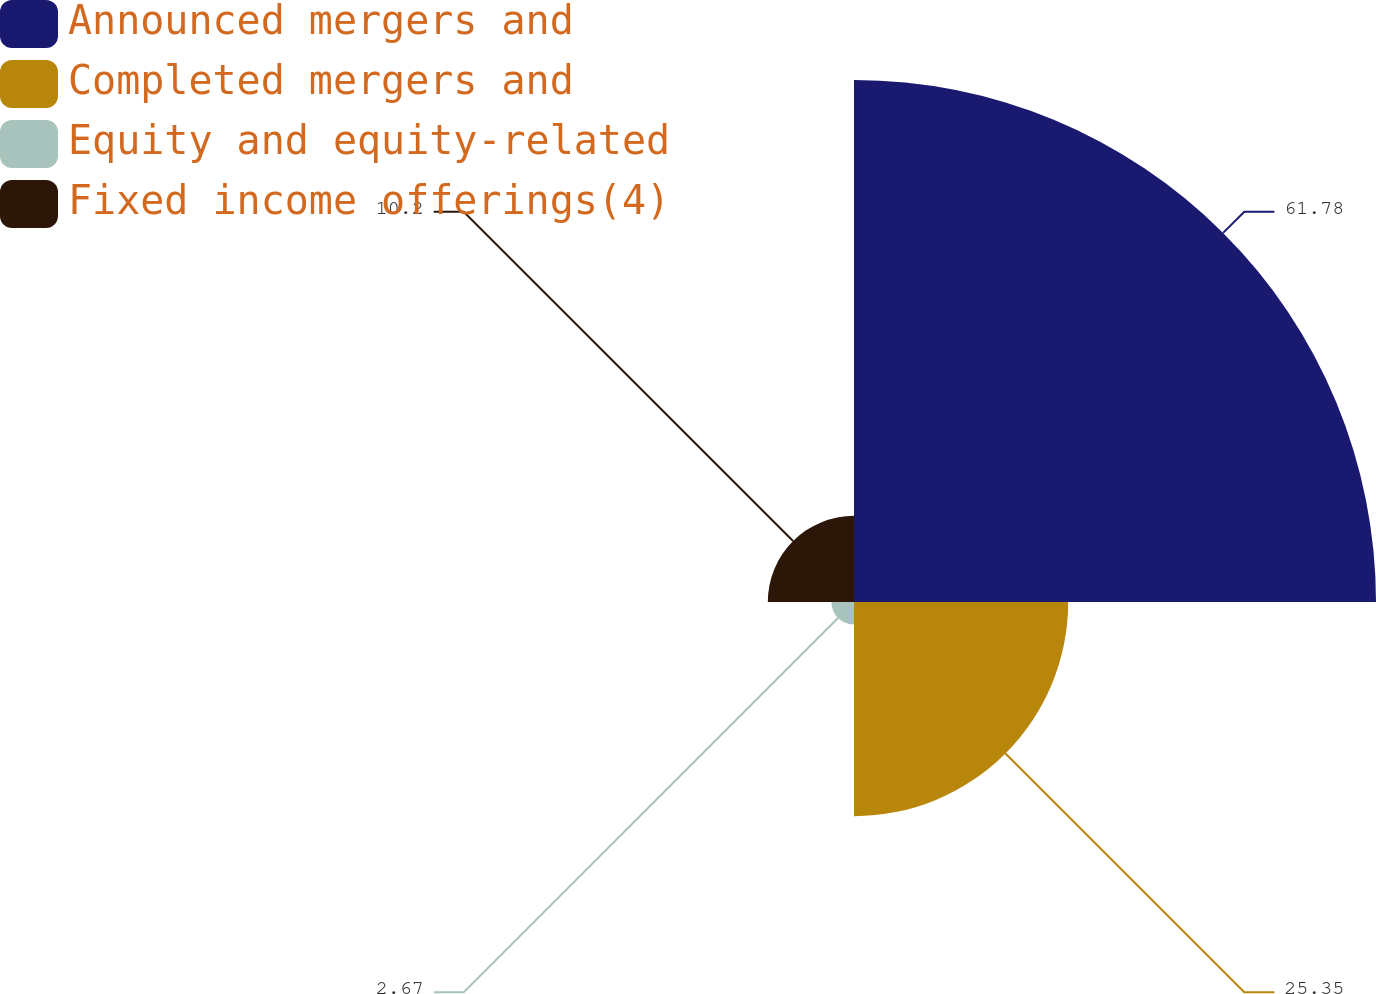Convert chart to OTSL. <chart><loc_0><loc_0><loc_500><loc_500><pie_chart><fcel>Announced mergers and<fcel>Completed mergers and<fcel>Equity and equity-related<fcel>Fixed income offerings(4)<nl><fcel>61.78%<fcel>25.35%<fcel>2.67%<fcel>10.2%<nl></chart> 